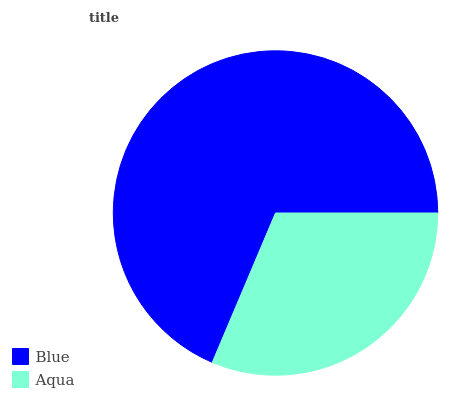Is Aqua the minimum?
Answer yes or no. Yes. Is Blue the maximum?
Answer yes or no. Yes. Is Aqua the maximum?
Answer yes or no. No. Is Blue greater than Aqua?
Answer yes or no. Yes. Is Aqua less than Blue?
Answer yes or no. Yes. Is Aqua greater than Blue?
Answer yes or no. No. Is Blue less than Aqua?
Answer yes or no. No. Is Blue the high median?
Answer yes or no. Yes. Is Aqua the low median?
Answer yes or no. Yes. Is Aqua the high median?
Answer yes or no. No. Is Blue the low median?
Answer yes or no. No. 